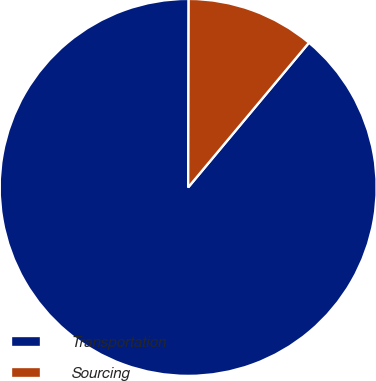Convert chart to OTSL. <chart><loc_0><loc_0><loc_500><loc_500><pie_chart><fcel>Transportation<fcel>Sourcing<nl><fcel>88.97%<fcel>11.03%<nl></chart> 